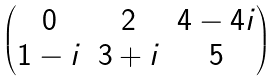Convert formula to latex. <formula><loc_0><loc_0><loc_500><loc_500>\begin{pmatrix} 0 & 2 & 4 - 4 i \\ 1 - i & 3 + i & 5 \end{pmatrix}</formula> 